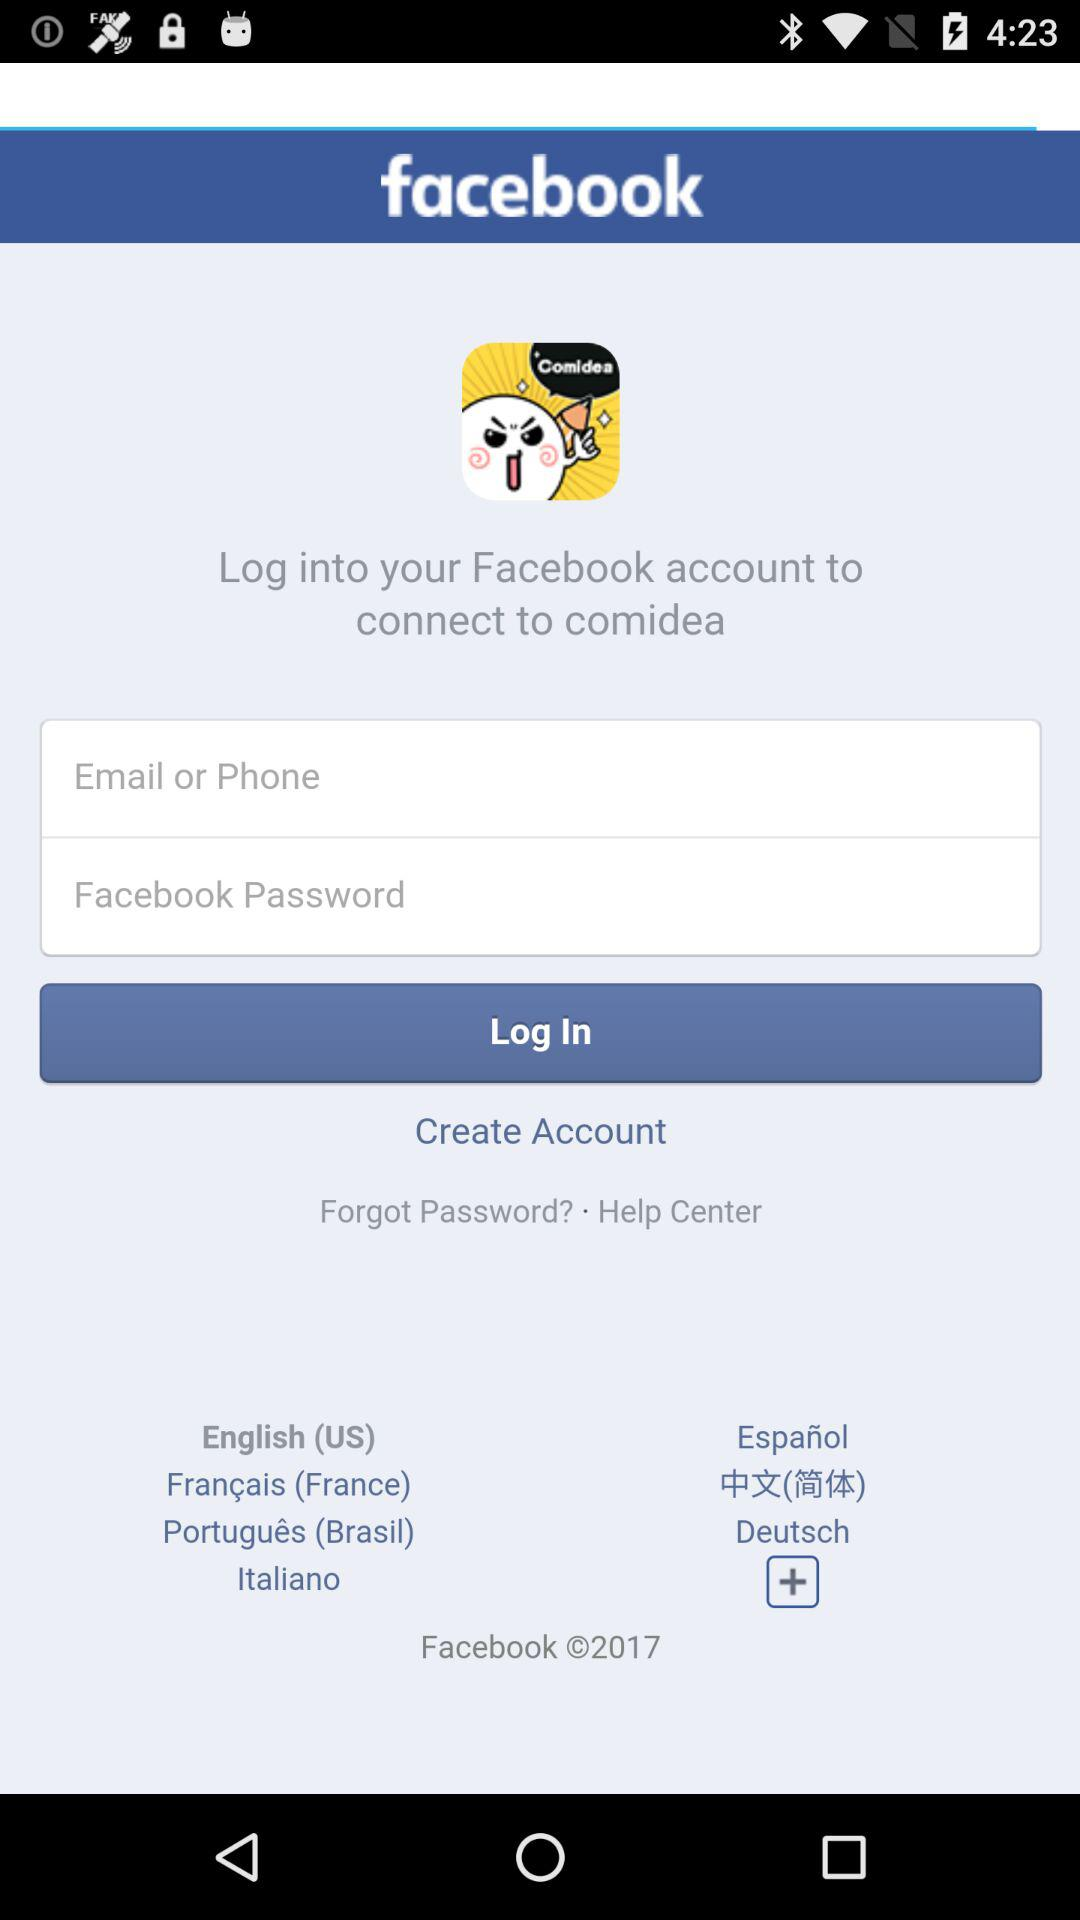Which application version is being used?
When the provided information is insufficient, respond with <no answer>. <no answer> 